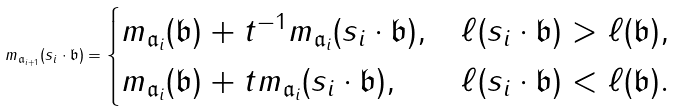Convert formula to latex. <formula><loc_0><loc_0><loc_500><loc_500>m _ { { \mathfrak { a } _ { i + 1 } } } ( s _ { i } \cdot \mathfrak { b } ) = \begin{cases} m _ { \mathfrak { a } _ { i } } ( \mathfrak { b } ) + t ^ { - 1 } m _ { \mathfrak { a } _ { i } } ( s _ { i } \cdot \mathfrak { b } ) , & \ell ( s _ { i } \cdot \mathfrak { b } ) > \ell ( \mathfrak { b } ) , \\ m _ { \mathfrak { a } _ { i } } ( \mathfrak { b } ) + t m _ { \mathfrak { a } _ { i } } ( s _ { i } \cdot \mathfrak { b } ) , & \ell ( s _ { i } \cdot \mathfrak { b } ) < \ell ( \mathfrak { b } ) . \end{cases}</formula> 